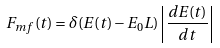Convert formula to latex. <formula><loc_0><loc_0><loc_500><loc_500>F _ { m f } ( t ) = \delta ( E ( t ) - E _ { 0 } L ) \left | \frac { d E ( t ) } { d t } \right |</formula> 